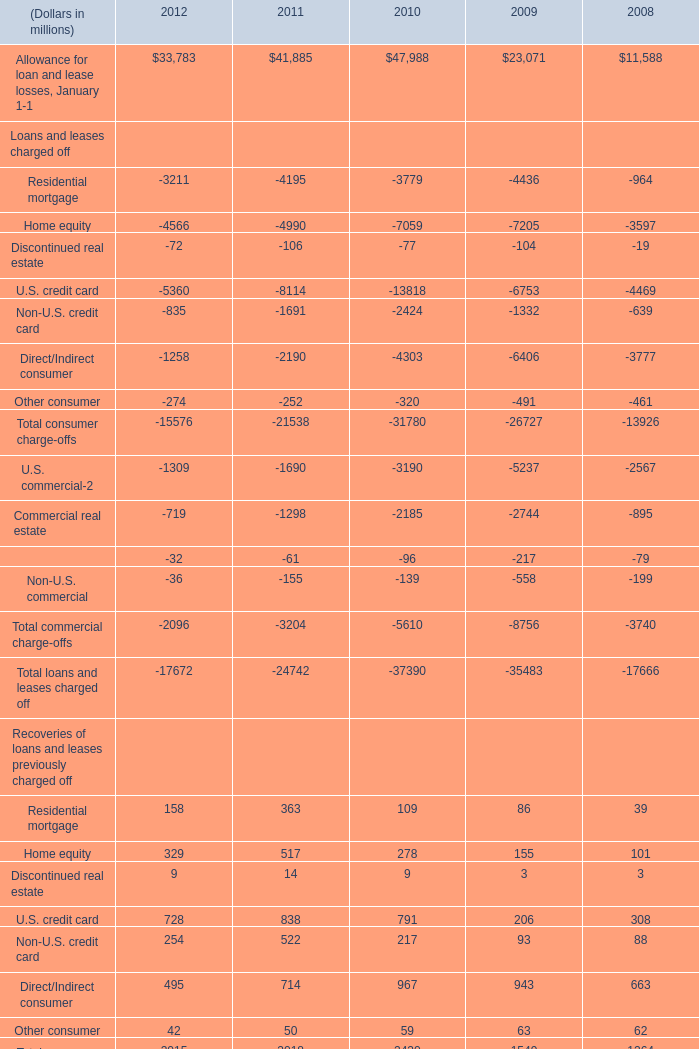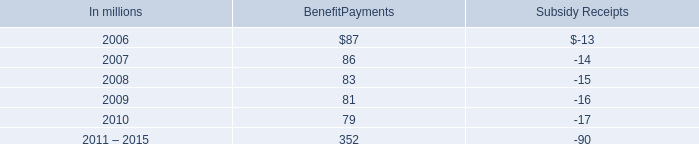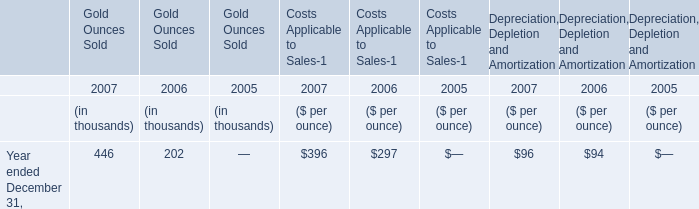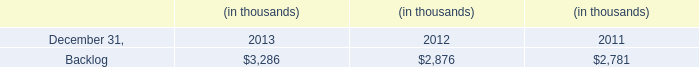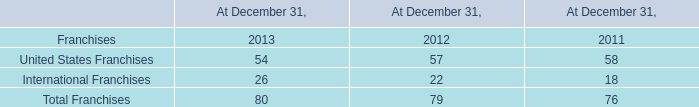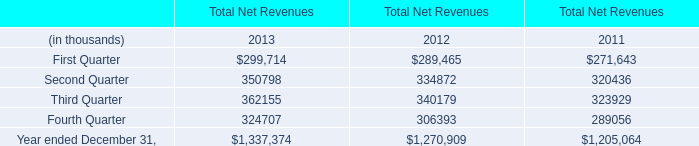What will commercial lease financing in terms of recoveries of loans and leases previously charged off reach in 2013 if it continues to grow at its current rate? (in million) 
Computations: (38 * (1 + ((38 - 37) / 37)))
Answer: 39.02703. 